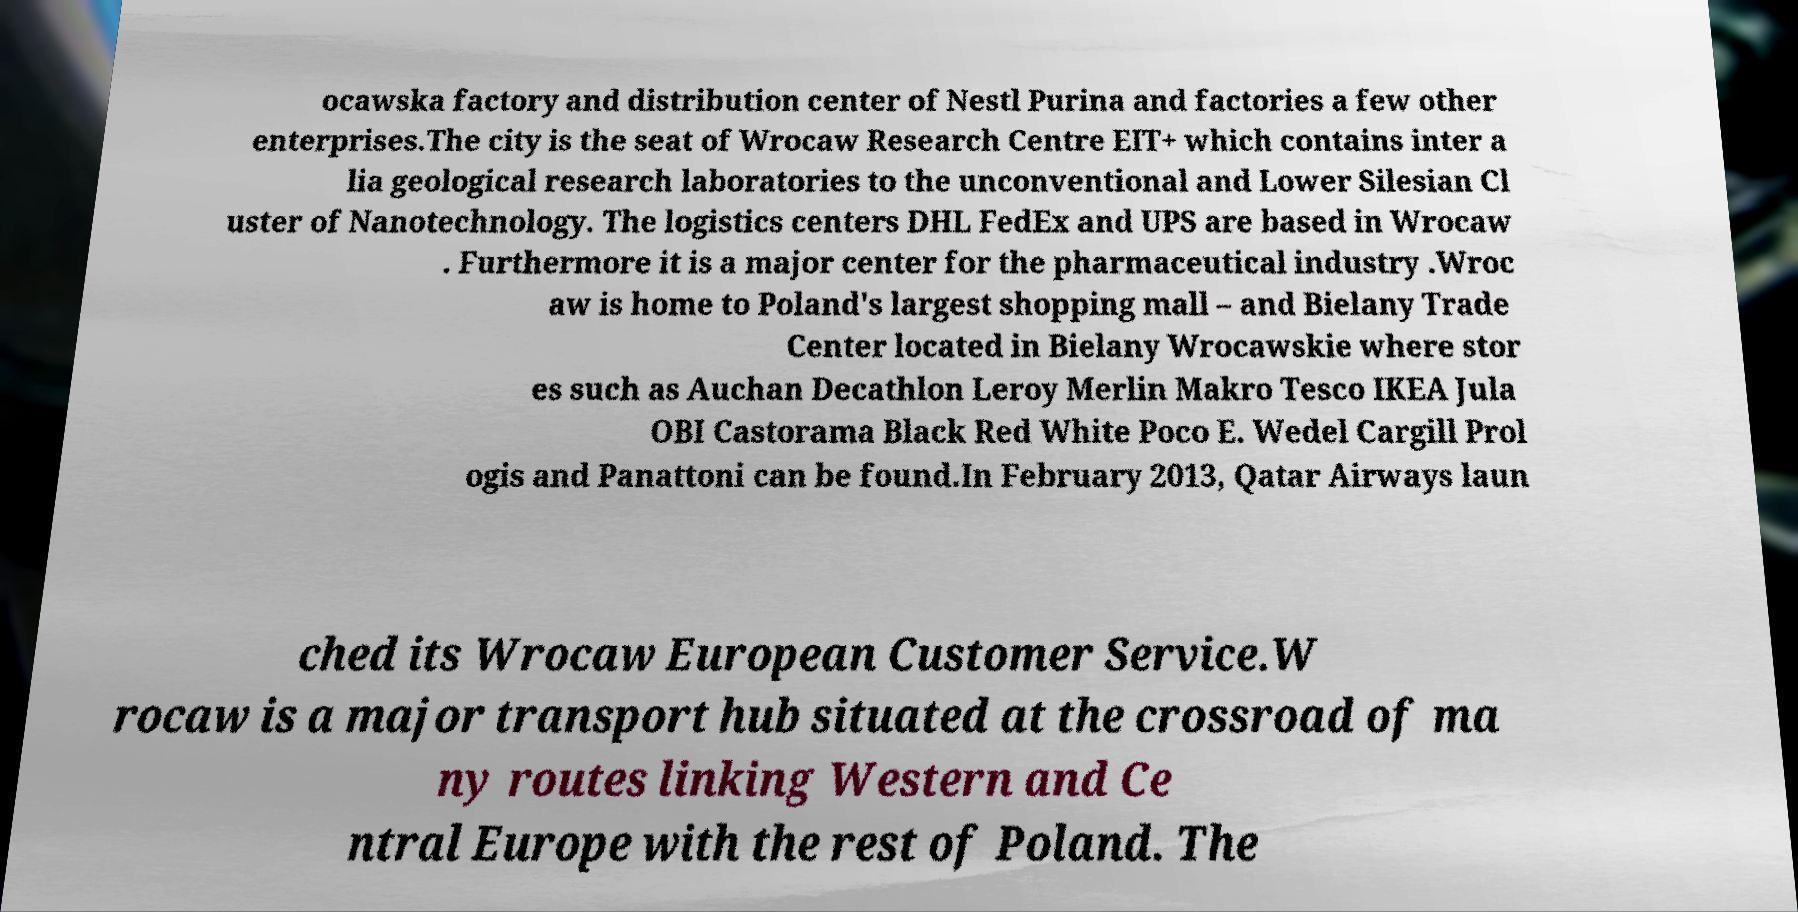I need the written content from this picture converted into text. Can you do that? ocawska factory and distribution center of Nestl Purina and factories a few other enterprises.The city is the seat of Wrocaw Research Centre EIT+ which contains inter a lia geological research laboratories to the unconventional and Lower Silesian Cl uster of Nanotechnology. The logistics centers DHL FedEx and UPS are based in Wrocaw . Furthermore it is a major center for the pharmaceutical industry .Wroc aw is home to Poland's largest shopping mall – and Bielany Trade Center located in Bielany Wrocawskie where stor es such as Auchan Decathlon Leroy Merlin Makro Tesco IKEA Jula OBI Castorama Black Red White Poco E. Wedel Cargill Prol ogis and Panattoni can be found.In February 2013, Qatar Airways laun ched its Wrocaw European Customer Service.W rocaw is a major transport hub situated at the crossroad of ma ny routes linking Western and Ce ntral Europe with the rest of Poland. The 